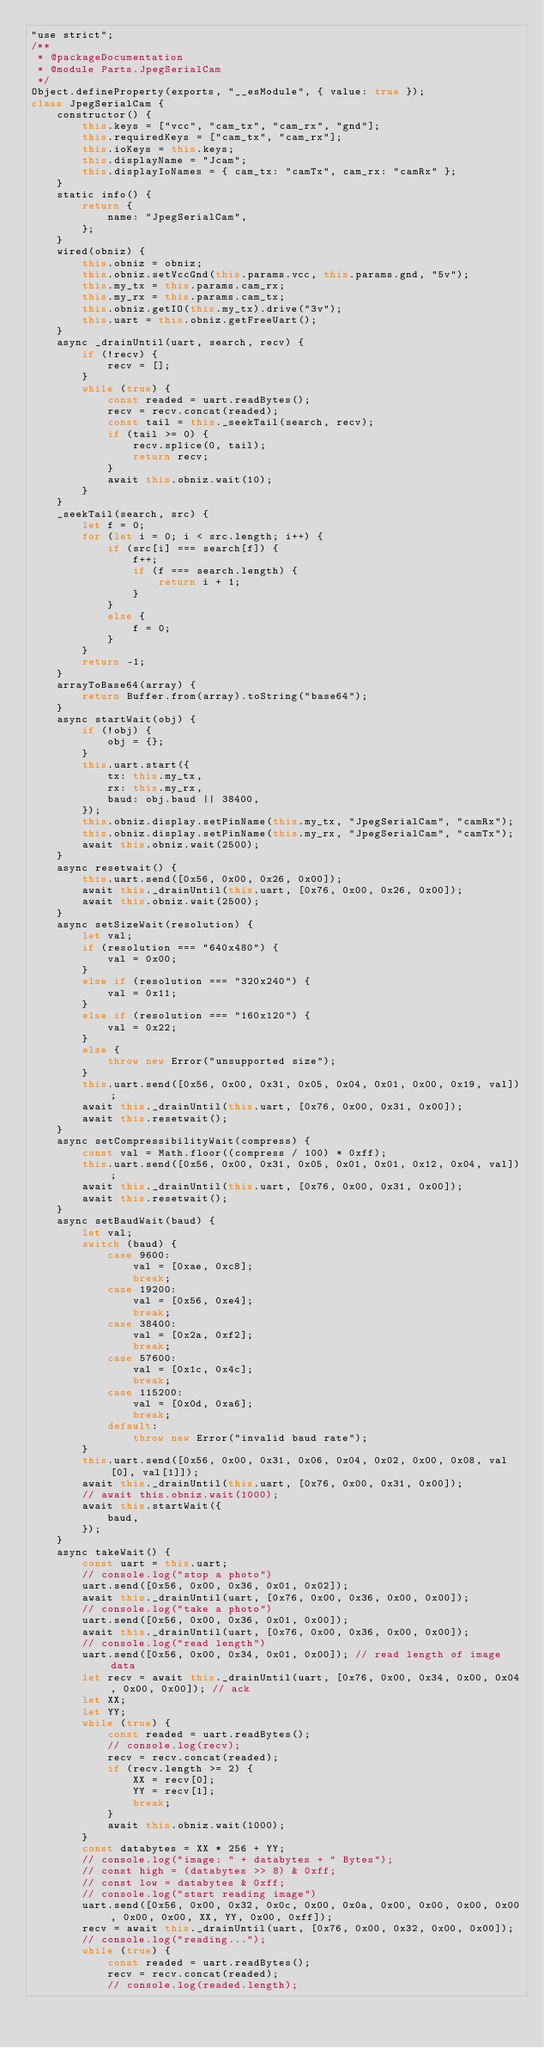<code> <loc_0><loc_0><loc_500><loc_500><_JavaScript_>"use strict";
/**
 * @packageDocumentation
 * @module Parts.JpegSerialCam
 */
Object.defineProperty(exports, "__esModule", { value: true });
class JpegSerialCam {
    constructor() {
        this.keys = ["vcc", "cam_tx", "cam_rx", "gnd"];
        this.requiredKeys = ["cam_tx", "cam_rx"];
        this.ioKeys = this.keys;
        this.displayName = "Jcam";
        this.displayIoNames = { cam_tx: "camTx", cam_rx: "camRx" };
    }
    static info() {
        return {
            name: "JpegSerialCam",
        };
    }
    wired(obniz) {
        this.obniz = obniz;
        this.obniz.setVccGnd(this.params.vcc, this.params.gnd, "5v");
        this.my_tx = this.params.cam_rx;
        this.my_rx = this.params.cam_tx;
        this.obniz.getIO(this.my_tx).drive("3v");
        this.uart = this.obniz.getFreeUart();
    }
    async _drainUntil(uart, search, recv) {
        if (!recv) {
            recv = [];
        }
        while (true) {
            const readed = uart.readBytes();
            recv = recv.concat(readed);
            const tail = this._seekTail(search, recv);
            if (tail >= 0) {
                recv.splice(0, tail);
                return recv;
            }
            await this.obniz.wait(10);
        }
    }
    _seekTail(search, src) {
        let f = 0;
        for (let i = 0; i < src.length; i++) {
            if (src[i] === search[f]) {
                f++;
                if (f === search.length) {
                    return i + 1;
                }
            }
            else {
                f = 0;
            }
        }
        return -1;
    }
    arrayToBase64(array) {
        return Buffer.from(array).toString("base64");
    }
    async startWait(obj) {
        if (!obj) {
            obj = {};
        }
        this.uart.start({
            tx: this.my_tx,
            rx: this.my_rx,
            baud: obj.baud || 38400,
        });
        this.obniz.display.setPinName(this.my_tx, "JpegSerialCam", "camRx");
        this.obniz.display.setPinName(this.my_rx, "JpegSerialCam", "camTx");
        await this.obniz.wait(2500);
    }
    async resetwait() {
        this.uart.send([0x56, 0x00, 0x26, 0x00]);
        await this._drainUntil(this.uart, [0x76, 0x00, 0x26, 0x00]);
        await this.obniz.wait(2500);
    }
    async setSizeWait(resolution) {
        let val;
        if (resolution === "640x480") {
            val = 0x00;
        }
        else if (resolution === "320x240") {
            val = 0x11;
        }
        else if (resolution === "160x120") {
            val = 0x22;
        }
        else {
            throw new Error("unsupported size");
        }
        this.uart.send([0x56, 0x00, 0x31, 0x05, 0x04, 0x01, 0x00, 0x19, val]);
        await this._drainUntil(this.uart, [0x76, 0x00, 0x31, 0x00]);
        await this.resetwait();
    }
    async setCompressibilityWait(compress) {
        const val = Math.floor((compress / 100) * 0xff);
        this.uart.send([0x56, 0x00, 0x31, 0x05, 0x01, 0x01, 0x12, 0x04, val]);
        await this._drainUntil(this.uart, [0x76, 0x00, 0x31, 0x00]);
        await this.resetwait();
    }
    async setBaudWait(baud) {
        let val;
        switch (baud) {
            case 9600:
                val = [0xae, 0xc8];
                break;
            case 19200:
                val = [0x56, 0xe4];
                break;
            case 38400:
                val = [0x2a, 0xf2];
                break;
            case 57600:
                val = [0x1c, 0x4c];
                break;
            case 115200:
                val = [0x0d, 0xa6];
                break;
            default:
                throw new Error("invalid baud rate");
        }
        this.uart.send([0x56, 0x00, 0x31, 0x06, 0x04, 0x02, 0x00, 0x08, val[0], val[1]]);
        await this._drainUntil(this.uart, [0x76, 0x00, 0x31, 0x00]);
        // await this.obniz.wait(1000);
        await this.startWait({
            baud,
        });
    }
    async takeWait() {
        const uart = this.uart;
        // console.log("stop a photo")
        uart.send([0x56, 0x00, 0x36, 0x01, 0x02]);
        await this._drainUntil(uart, [0x76, 0x00, 0x36, 0x00, 0x00]);
        // console.log("take a photo")
        uart.send([0x56, 0x00, 0x36, 0x01, 0x00]);
        await this._drainUntil(uart, [0x76, 0x00, 0x36, 0x00, 0x00]);
        // console.log("read length")
        uart.send([0x56, 0x00, 0x34, 0x01, 0x00]); // read length of image data
        let recv = await this._drainUntil(uart, [0x76, 0x00, 0x34, 0x00, 0x04, 0x00, 0x00]); // ack
        let XX;
        let YY;
        while (true) {
            const readed = uart.readBytes();
            // console.log(recv);
            recv = recv.concat(readed);
            if (recv.length >= 2) {
                XX = recv[0];
                YY = recv[1];
                break;
            }
            await this.obniz.wait(1000);
        }
        const databytes = XX * 256 + YY;
        // console.log("image: " + databytes + " Bytes");
        // const high = (databytes >> 8) & 0xff;
        // const low = databytes & 0xff;
        // console.log("start reading image")
        uart.send([0x56, 0x00, 0x32, 0x0c, 0x00, 0x0a, 0x00, 0x00, 0x00, 0x00, 0x00, 0x00, XX, YY, 0x00, 0xff]);
        recv = await this._drainUntil(uart, [0x76, 0x00, 0x32, 0x00, 0x00]);
        // console.log("reading...");
        while (true) {
            const readed = uart.readBytes();
            recv = recv.concat(readed);
            // console.log(readed.length);</code> 